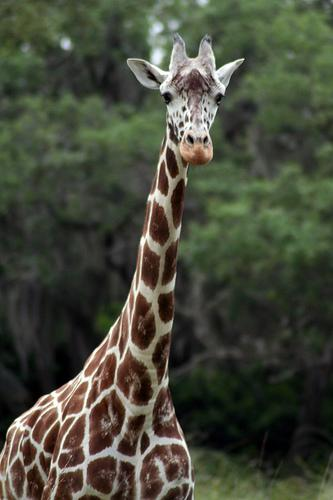Question: why is it there?
Choices:
A. To use.
B. To throw away.
C. To see.
D. To wash.
Answer with the letter. Answer: C Question: what is behind the giraffe?
Choices:
A. Bushes.
B. Food trough.
C. Trees.
D. Water bucket.
Answer with the letter. Answer: C Question: when will it move?
Choices:
A. Never.
B. Tomorrow.
C. Soon.
D. Tonight.
Answer with the letter. Answer: C Question: how many giraffes?
Choices:
A. 2.
B. 1.
C. 3.
D. 4.
Answer with the letter. Answer: B Question: where are the trees?
Choices:
A. Next to the bushes.
B. In front of the giraffe.
C. Next to the giraffe.
D. Behind the giraffe.
Answer with the letter. Answer: D 